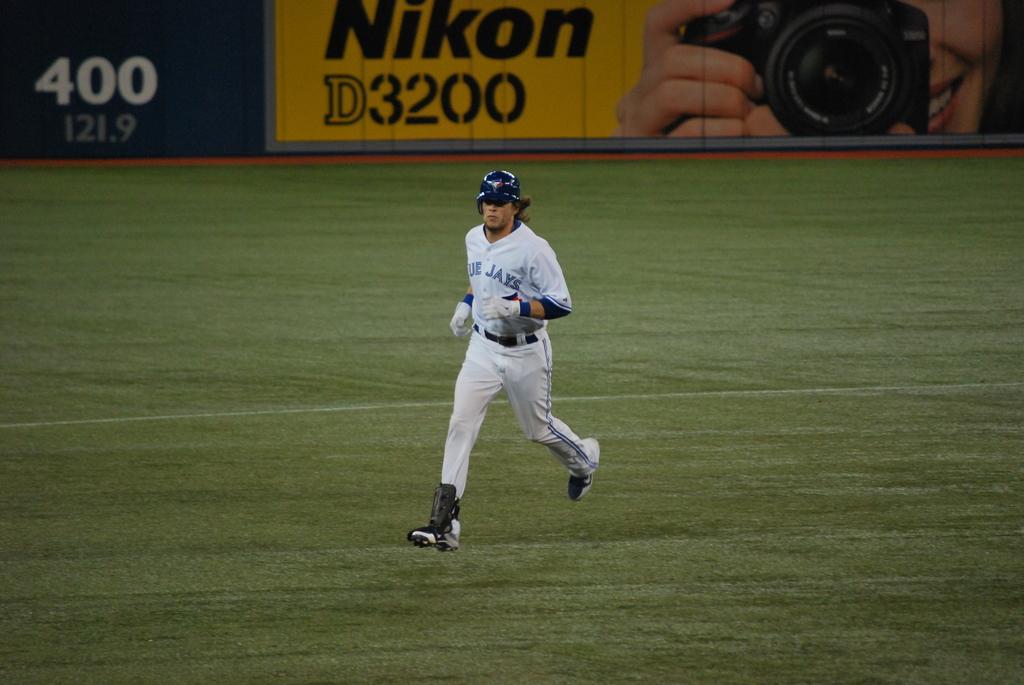What camera advertisement is in the background?
Offer a terse response. Nikon. What team does he play for?
Provide a succinct answer. Blue jays. 